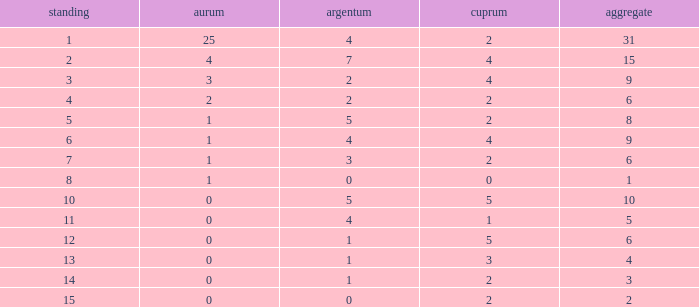With a medal tally below 15, containing more than 2 bronzes, 0 golds, and 1 silver, what is the highest achievable ranking? 13.0. 